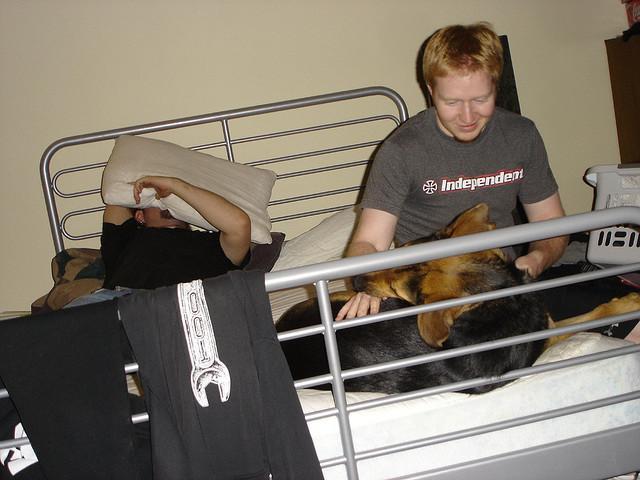What tool is printed on the shirt on the railing?
Choose the right answer and clarify with the format: 'Answer: answer
Rationale: rationale.'
Options: Hammer, chisel, screwdriver, wrench. Answer: wrench.
Rationale: The shirt on the railing has a silver wrench on it. 